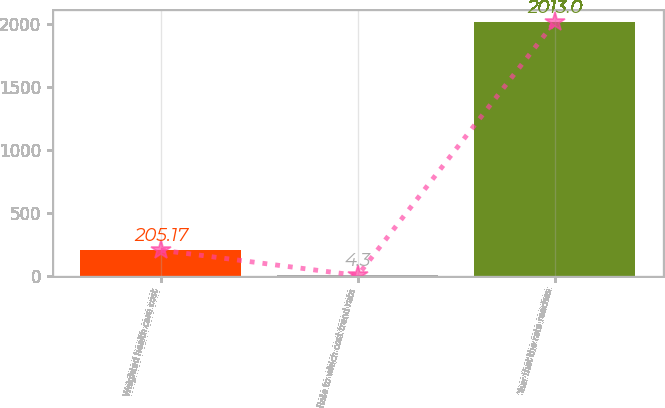Convert chart. <chart><loc_0><loc_0><loc_500><loc_500><bar_chart><fcel>Weighted health care cost<fcel>Rate to which cost trend rate<fcel>Year that the rate reaches<nl><fcel>205.17<fcel>4.3<fcel>2013<nl></chart> 